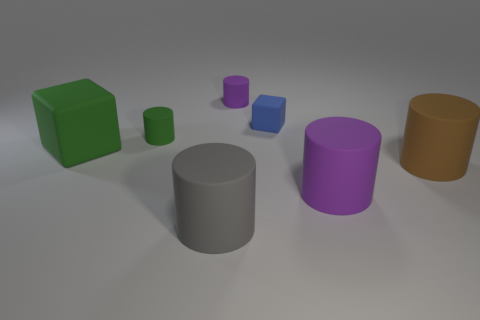Add 1 tiny green rubber cubes. How many objects exist? 8 Subtract all red spheres. How many purple cylinders are left? 2 Subtract all tiny cylinders. How many cylinders are left? 3 Subtract 1 cylinders. How many cylinders are left? 4 Subtract all brown cylinders. How many cylinders are left? 4 Subtract all blocks. How many objects are left? 5 Subtract all gray cylinders. Subtract all cyan blocks. How many cylinders are left? 4 Subtract 1 gray cylinders. How many objects are left? 6 Subtract all small purple shiny objects. Subtract all big gray things. How many objects are left? 6 Add 6 big gray rubber objects. How many big gray rubber objects are left? 7 